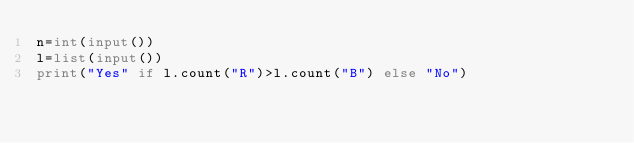Convert code to text. <code><loc_0><loc_0><loc_500><loc_500><_Python_>n=int(input())
l=list(input())
print("Yes" if l.count("R")>l.count("B") else "No")</code> 